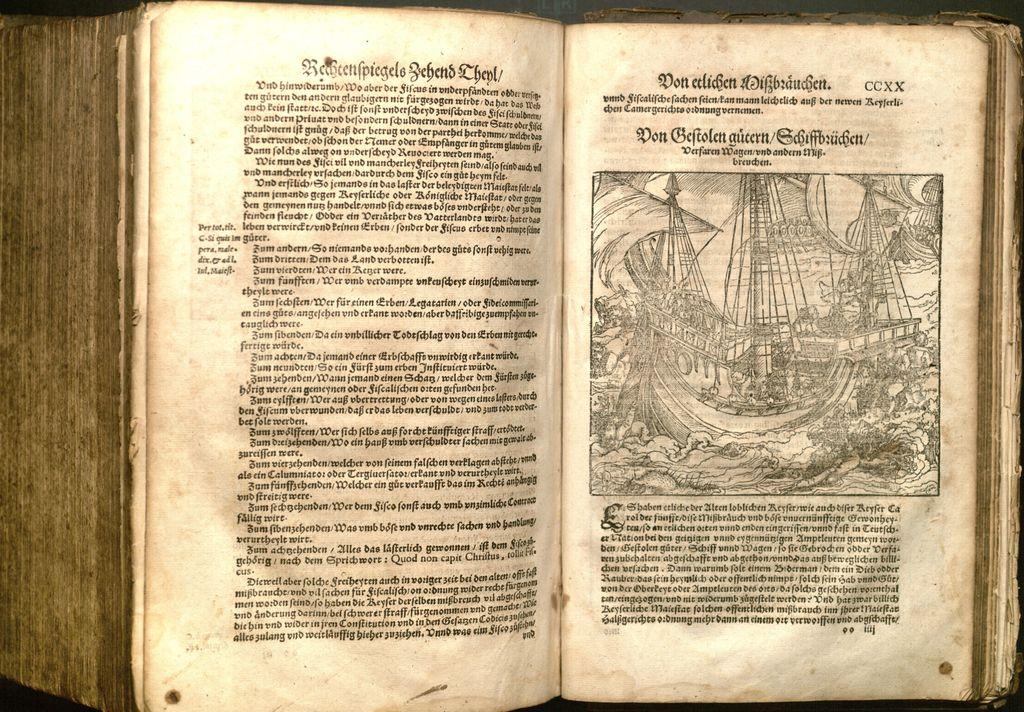What letters are on the top right corner of the second page?
Ensure brevity in your answer.  Ccxx. 